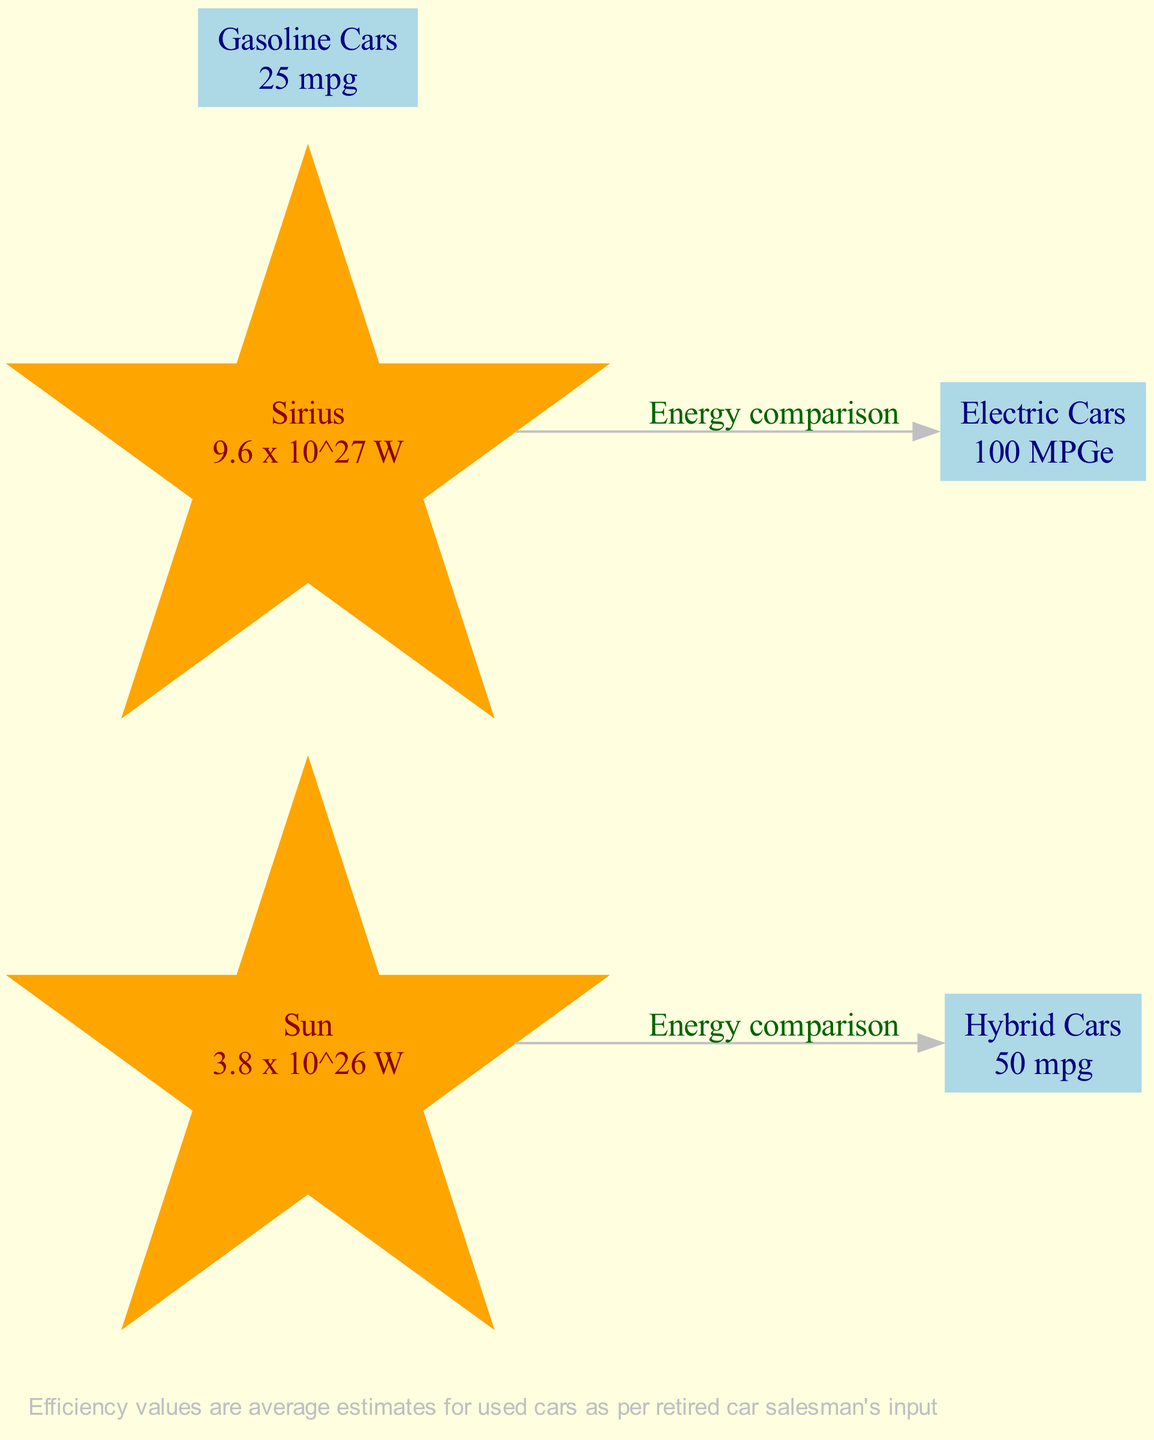What is the energy output of the Sun? The diagram lists the energy output of the Sun as "3.8 x 10^26 W". This information is directly accessible from the node labeled "Sun".
Answer: 3.8 x 10^26 W What is the fuel efficiency of hybrid cars? The node for hybrid cars displays the fuel efficiency as "50 mpg". This value is found directly under the "Hybrid Cars" label in the diagram.
Answer: 50 mpg How many total nodes are in the diagram? There are five nodes in the diagram: Sun, Sirius, Hybrid Cars, Electric Cars, and Gasoline Cars. By counting the individual node entries, we see that there are five in total.
Answer: 5 What is the fuel efficiency of electric cars? Referring to the node for Electric Cars, the fuel efficiency is labeled as "100 MPGe". This value is specified at the corresponding node.
Answer: 100 MPGe Which celestial body has the highest energy output shown in the diagram? The diagram shows Sirius with an energy output of "9.6 x 10^27 W", which is higher than the Sun's output of "3.8 x 10^26 W". Therefore, Sirius has the highest energy output.
Answer: Sirius Which type of car is compared to the Sun? The edge labeled "Energy comparison" connects the Sun to the Hybrid Cars node. This indicates that the fuel efficiency of hybrid cars is being compared with the energy output of the Sun.
Answer: Hybrid Cars What is the relationship between Sirius and electric cars based on the diagram? The diagram indicates an "Energy comparison" edge connecting Sirius to Electric Cars, which signifies a comparison between the two regarding their energy outputs.
Answer: Energy comparison How does the efficiency of gasoline cars compare to that of hybrid cars? According to the nodes, gasoline cars have an efficiency of "25 mpg," which is less than the "50 mpg" efficiency of hybrid cars. Thus, hybrid cars are more efficient than gasoline cars.
Answer: Hybrid cars are more efficient What type of cars is the least fuel-efficient according to the diagram? The node for Gasoline Cars shows a fuel efficiency of "25 mpg," which is the lowest compared to the other car types referenced.
Answer: Gasoline Cars 